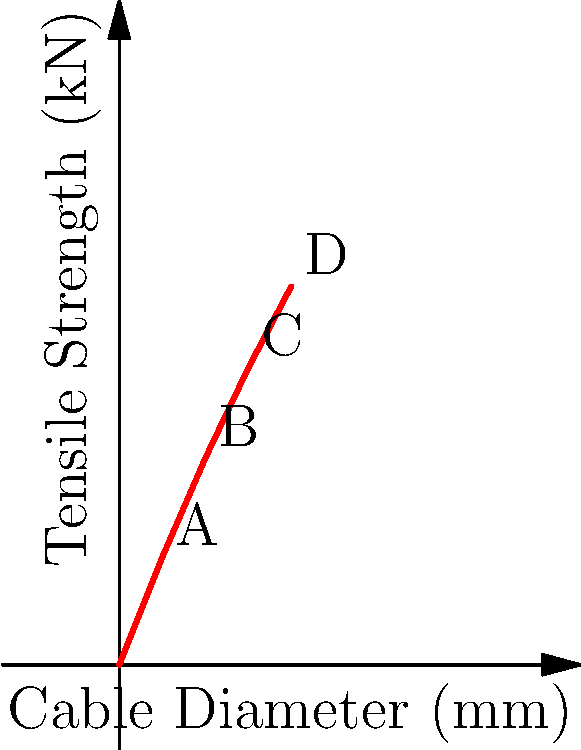In modern soccer goal nets, the tensile strength of cables is crucial for durability and safety. The graph shows the relationship between cable diameter and tensile strength for different types of goal net cables. If a soccer association requires goal net cables with a minimum tensile strength of 7 kN, what is the minimum cable diameter needed to meet this requirement? To solve this problem, we need to follow these steps:

1. Understand the graph: The x-axis represents the cable diameter in millimeters, and the y-axis represents the tensile strength in kilonewtons (kN).

2. Identify the requirement: We need to find a cable with a tensile strength of at least 7 kN.

3. Analyze the data points:
   A: 1 mm diameter - 2.5 kN
   B: 2 mm diameter - 4.8 kN
   C: 3 mm diameter - 6.9 kN
   D: 4 mm diameter - 8.8 kN

4. Find the first point that exceeds 7 kN: Point D (4 mm diameter, 8.8 kN) is the first point that surpasses 7 kN.

5. Interpolate between points C and D:
   We need to find a value between 3 mm and 4 mm that corresponds to 7 kN.

   Using linear interpolation:
   $$(x - 3) / (4 - 3) = (7 - 6.9) / (8.8 - 6.9)$$
   $$x - 3 = (7 - 6.9) / 1.9$$
   $$x - 3 = 0.0526$$
   $$x = 3.0526$$

6. Round up to the nearest practical measurement: 3.1 mm

Therefore, the minimum cable diameter needed to meet the 7 kN tensile strength requirement is approximately 3.1 mm.
Answer: 3.1 mm 